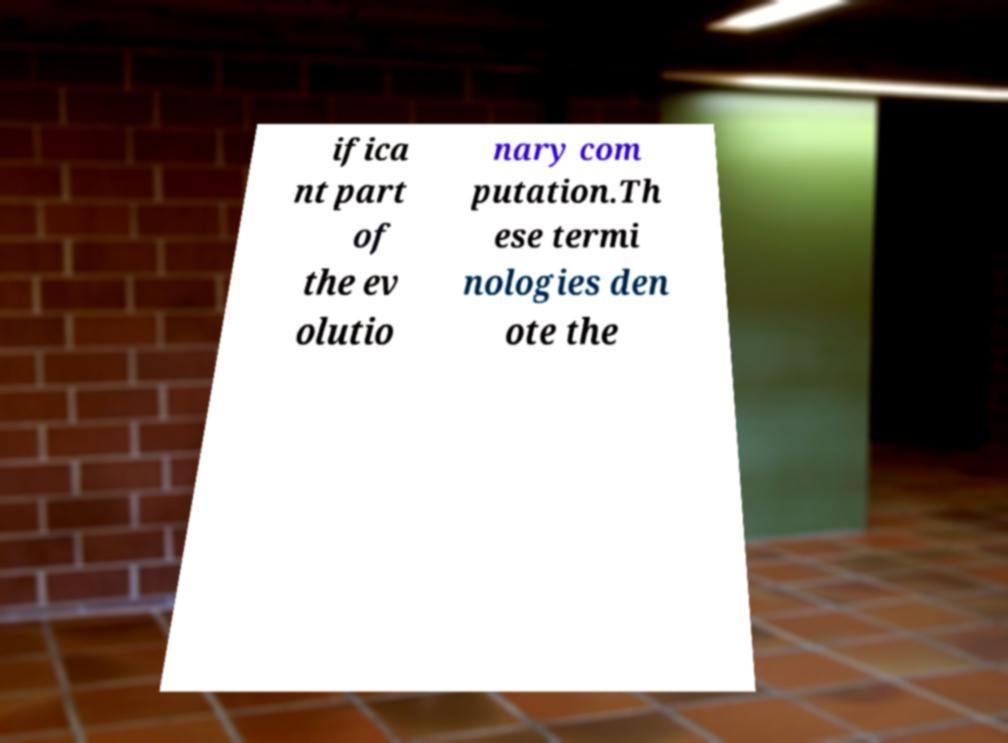Can you read and provide the text displayed in the image?This photo seems to have some interesting text. Can you extract and type it out for me? ifica nt part of the ev olutio nary com putation.Th ese termi nologies den ote the 